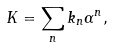Convert formula to latex. <formula><loc_0><loc_0><loc_500><loc_500>K = \sum _ { n } k _ { n } \alpha ^ { n } ,</formula> 